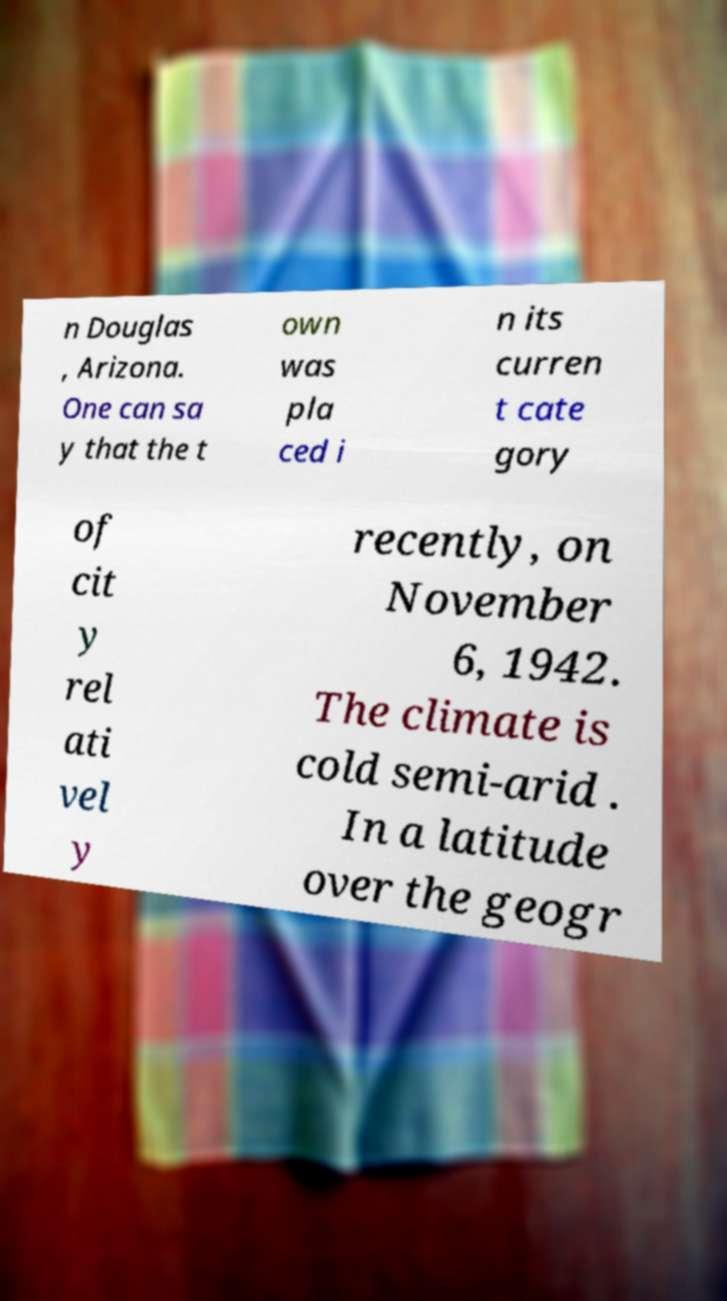Please identify and transcribe the text found in this image. n Douglas , Arizona. One can sa y that the t own was pla ced i n its curren t cate gory of cit y rel ati vel y recently, on November 6, 1942. The climate is cold semi-arid . In a latitude over the geogr 